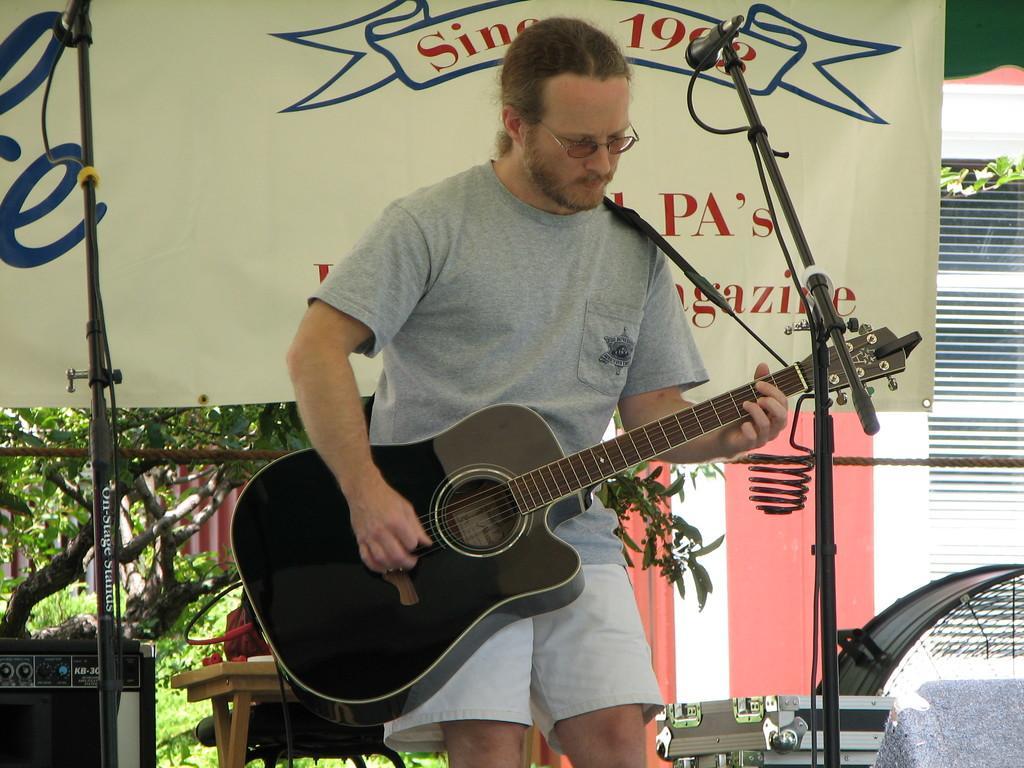Could you give a brief overview of what you see in this image? In this picture a man is standing and playing a guitar, he is wearing at-shirt ,and here is a hoarding, and here is a microphone with the stand. here is the table and at the back side there are trees. 